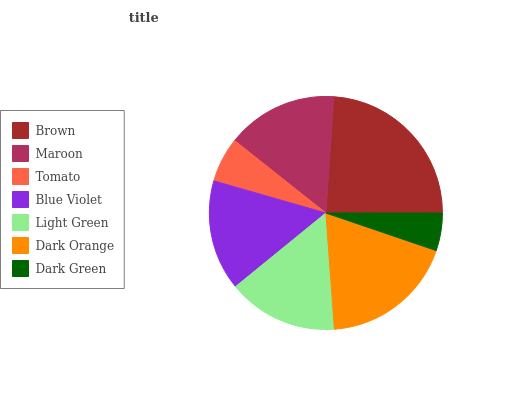Is Dark Green the minimum?
Answer yes or no. Yes. Is Brown the maximum?
Answer yes or no. Yes. Is Maroon the minimum?
Answer yes or no. No. Is Maroon the maximum?
Answer yes or no. No. Is Brown greater than Maroon?
Answer yes or no. Yes. Is Maroon less than Brown?
Answer yes or no. Yes. Is Maroon greater than Brown?
Answer yes or no. No. Is Brown less than Maroon?
Answer yes or no. No. Is Blue Violet the high median?
Answer yes or no. Yes. Is Blue Violet the low median?
Answer yes or no. Yes. Is Brown the high median?
Answer yes or no. No. Is Tomato the low median?
Answer yes or no. No. 